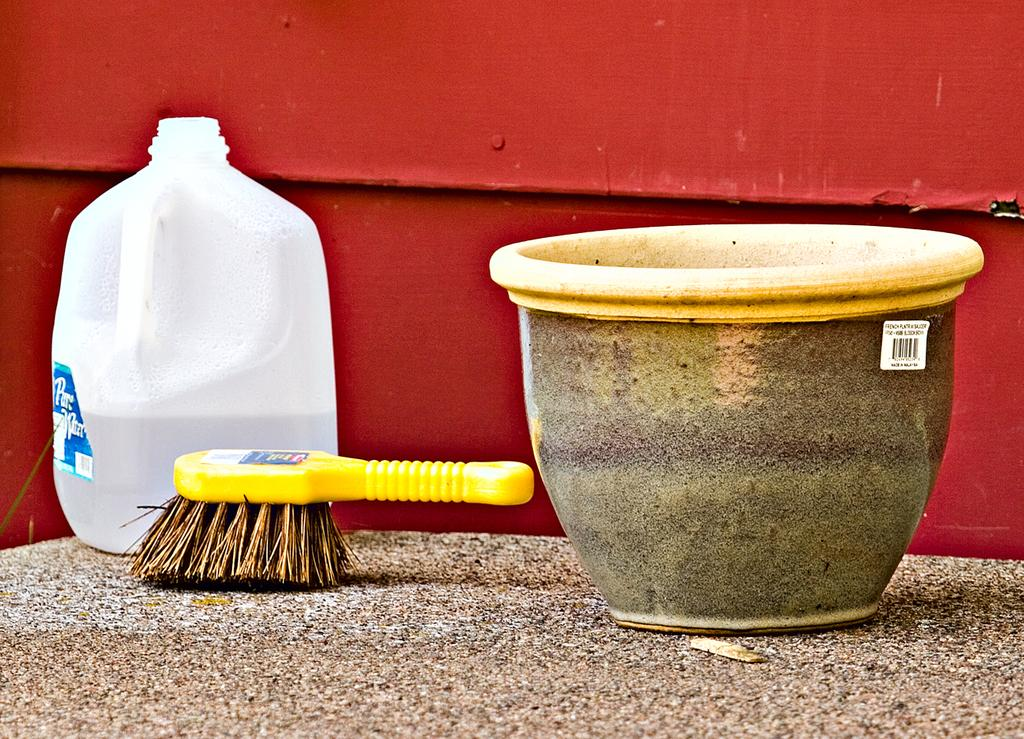What type of pot is in the image? There is a clay pot in the image. What tool is visible in the image? There is a brush in the image. What is used for storing water in the image? There is a water storage Kane in the image. What material is the table made of? The table is made of marble. What is the metal block in the image used for? The metal block is painted with red color paint, but its specific use is not mentioned. What type of lace is draped over the clay pot in the image? There is no lace present in the image; it only features a clay pot, a brush, a water storage Kane, a marble table, a metal block, and red color paint. 